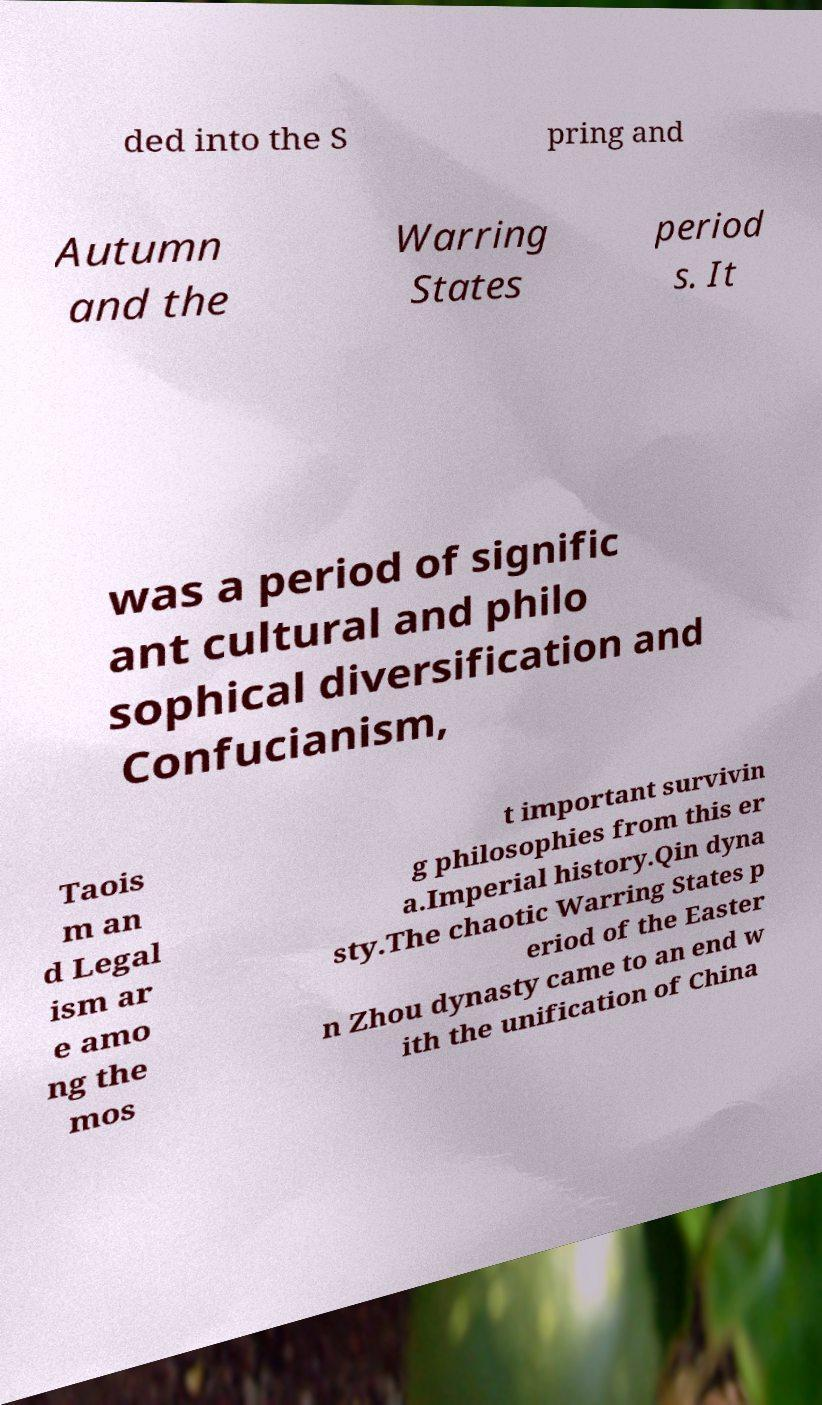Could you assist in decoding the text presented in this image and type it out clearly? ded into the S pring and Autumn and the Warring States period s. It was a period of signific ant cultural and philo sophical diversification and Confucianism, Taois m an d Legal ism ar e amo ng the mos t important survivin g philosophies from this er a.Imperial history.Qin dyna sty.The chaotic Warring States p eriod of the Easter n Zhou dynasty came to an end w ith the unification of China 